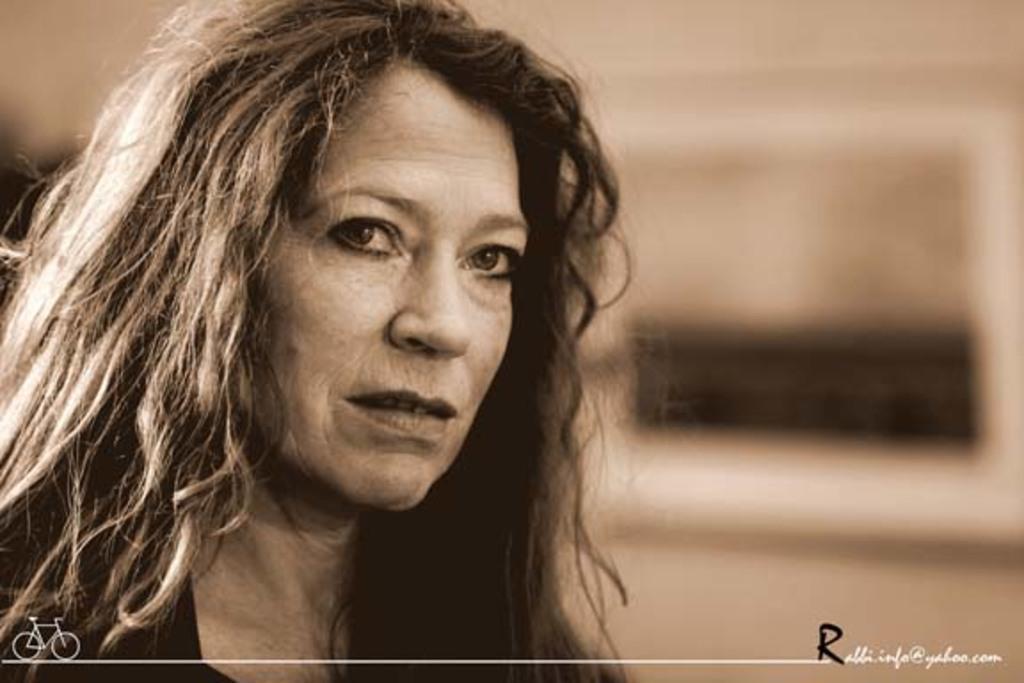How would you summarize this image in a sentence or two? This is a woman and a bicycle. 